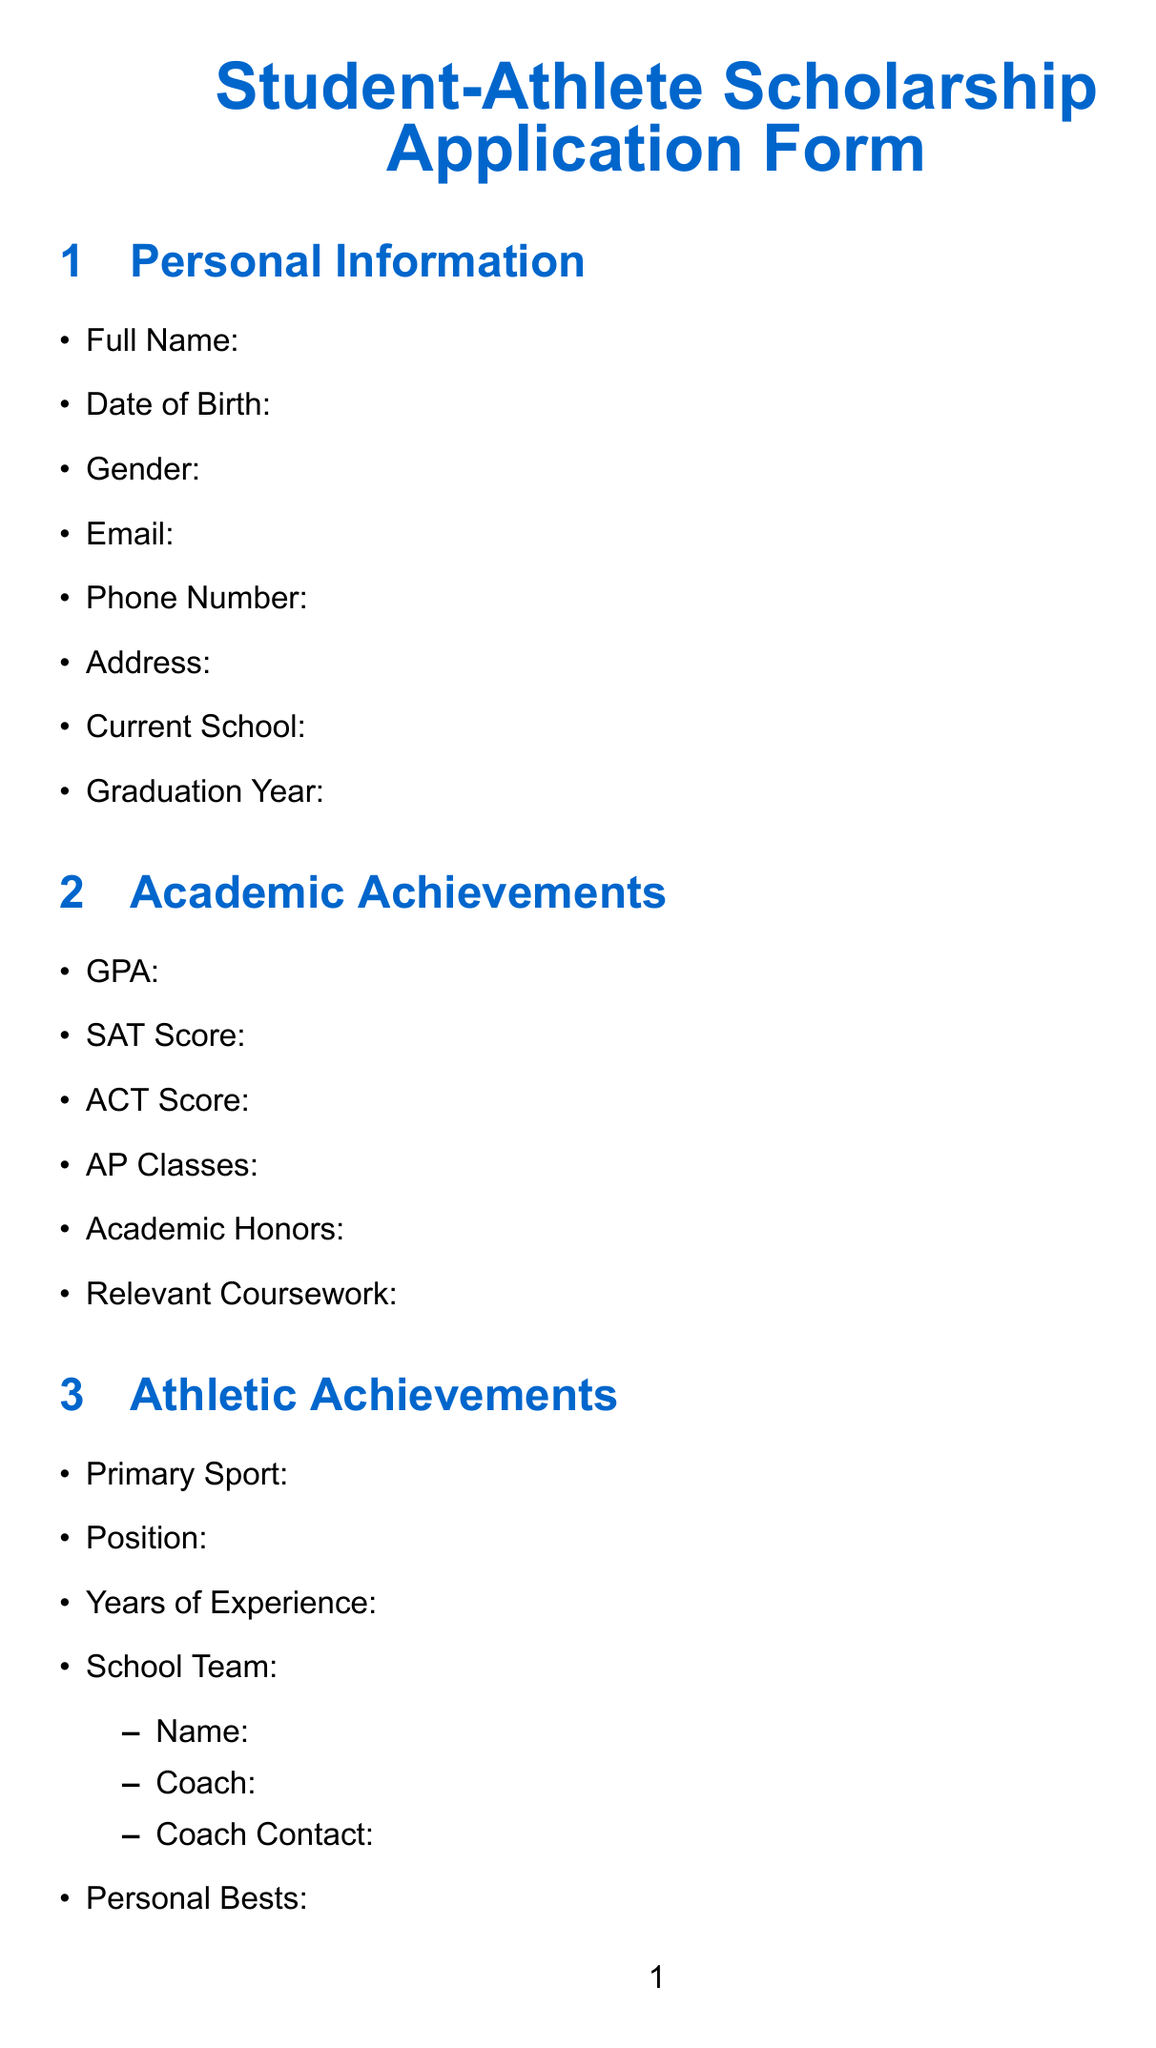what is the title of the form? The title of the form is presented at the top of the document and indicates the purpose of the document.
Answer: Student-Athlete Scholarship Application Form what is one of the essay prompt questions? The essay prompts encourage applicants to reflect on their experiences and challenges as student-athletes.
Answer: Describe how your experience as a student-athlete has shaped your character and prepared you for future challenges what title does the document use for the personal information section? The personal information section is clearly labeled, guiding the applicant to provide their basic details.
Answer: Personal Information what type of additional information is required in the document? Additional information is specified to cover unique aspects of the athlete's profile, which can influence the scholarship decision.
Answer: Injuries, Nutrition Plan, Career Goals 